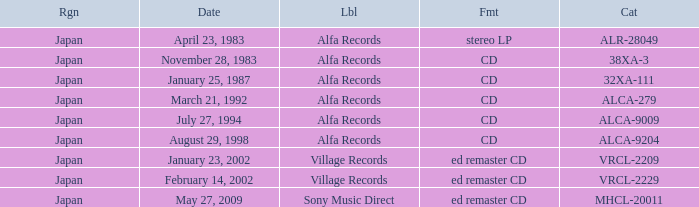Which catalog is in cd format? 38XA-3, 32XA-111, ALCA-279, ALCA-9009, ALCA-9204. 